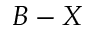<formula> <loc_0><loc_0><loc_500><loc_500>B - X</formula> 